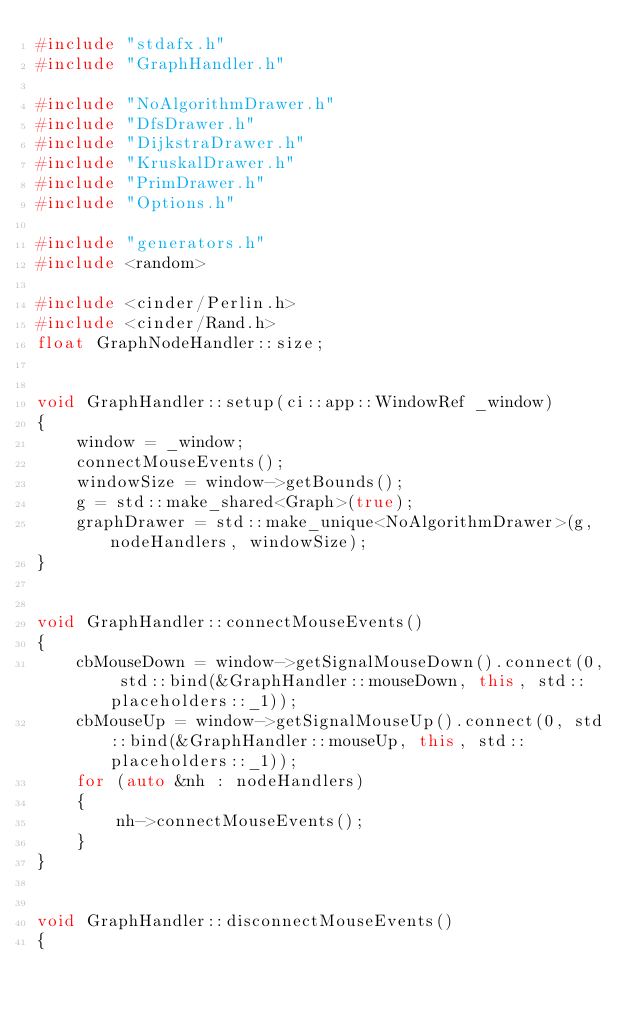Convert code to text. <code><loc_0><loc_0><loc_500><loc_500><_C++_>#include "stdafx.h"
#include "GraphHandler.h"

#include "NoAlgorithmDrawer.h"
#include "DfsDrawer.h"
#include "DijkstraDrawer.h"
#include "KruskalDrawer.h"
#include "PrimDrawer.h"
#include "Options.h"

#include "generators.h"
#include <random>

#include <cinder/Perlin.h>
#include <cinder/Rand.h>
float GraphNodeHandler::size;


void GraphHandler::setup(ci::app::WindowRef _window)
{
    window = _window;
	connectMouseEvents();
    windowSize = window->getBounds();    
    g = std::make_shared<Graph>(true);
    graphDrawer = std::make_unique<NoAlgorithmDrawer>(g, nodeHandlers, windowSize);
}


void GraphHandler::connectMouseEvents()
{
	cbMouseDown = window->getSignalMouseDown().connect(0, std::bind(&GraphHandler::mouseDown, this, std::placeholders::_1));
	cbMouseUp = window->getSignalMouseUp().connect(0, std::bind(&GraphHandler::mouseUp, this, std::placeholders::_1));
	for (auto &nh : nodeHandlers)
	{
		nh->connectMouseEvents();
	}
}


void GraphHandler::disconnectMouseEvents()
{</code> 